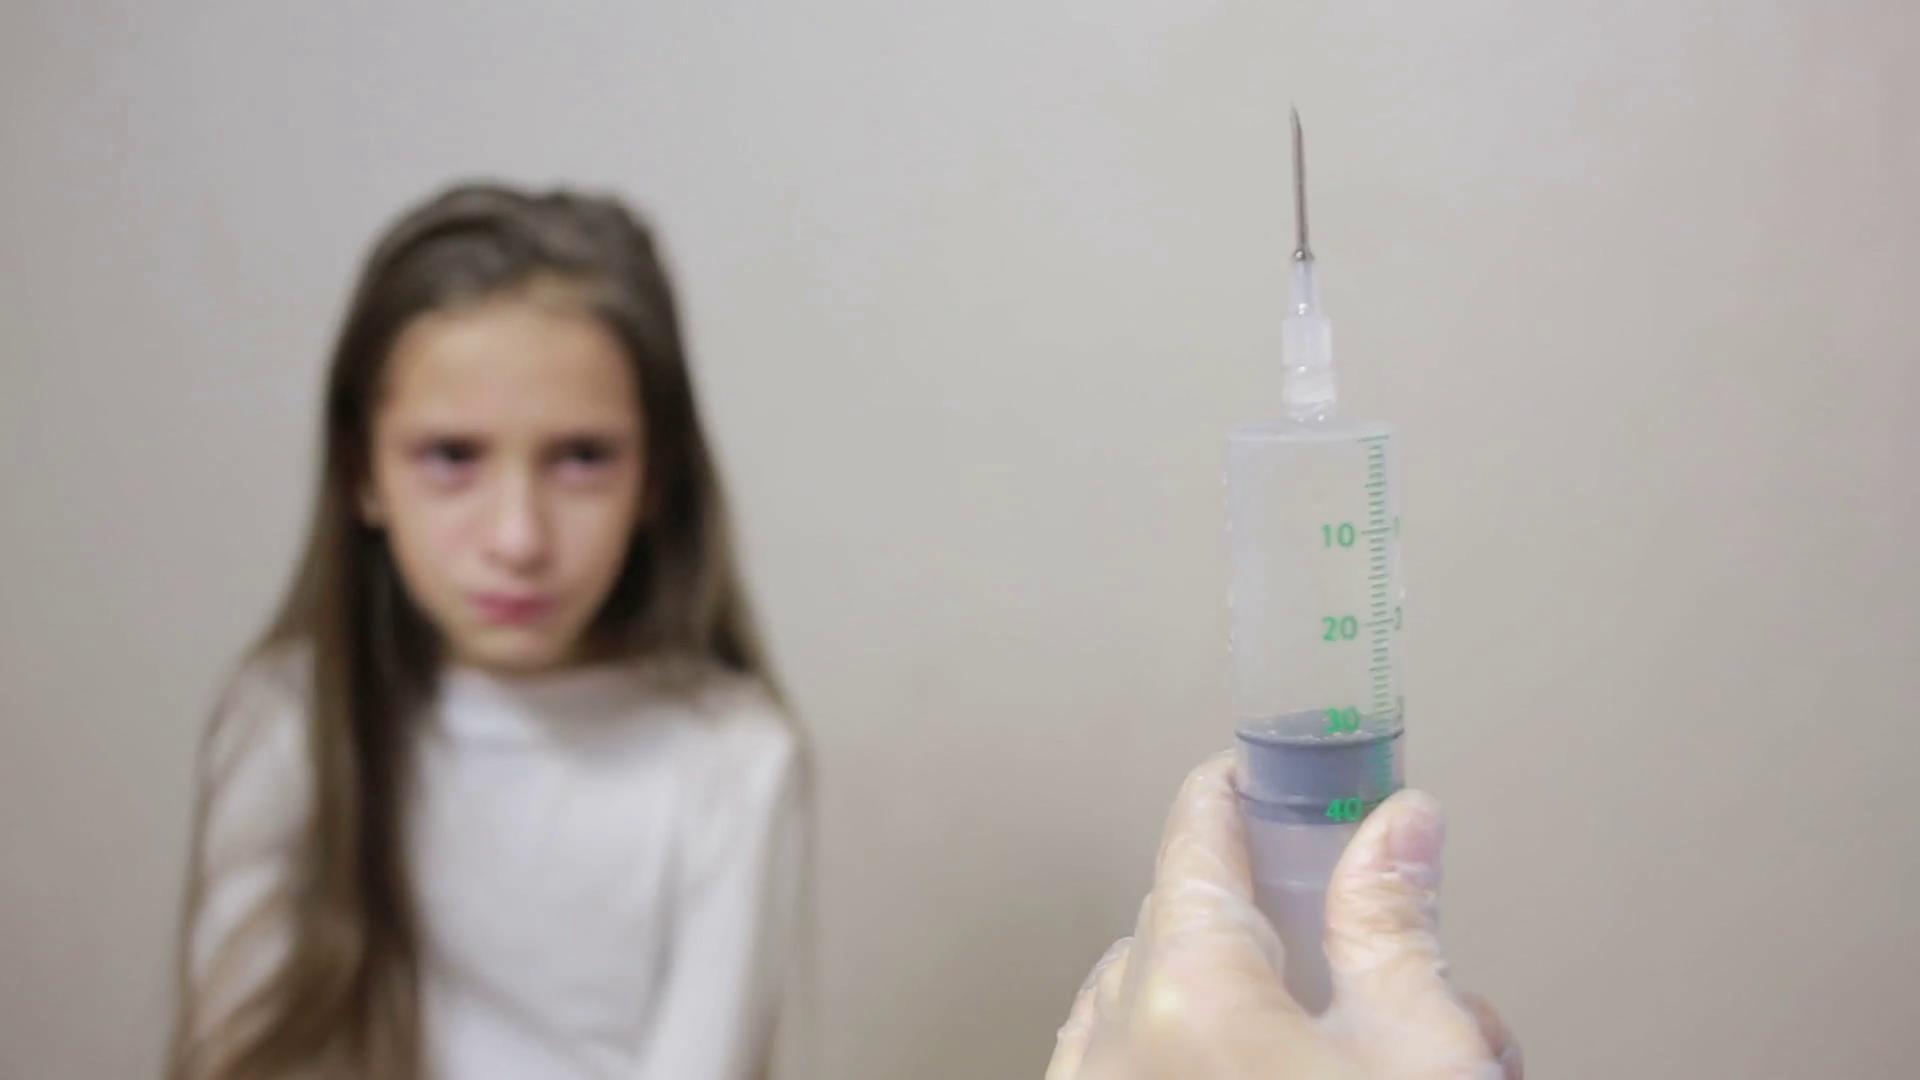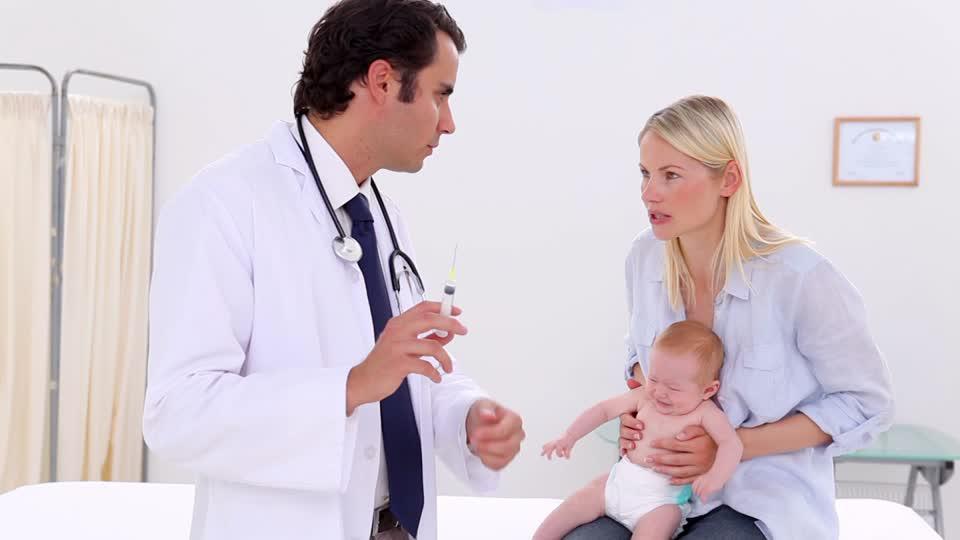The first image is the image on the left, the second image is the image on the right. Given the left and right images, does the statement "The left and right image contains two doctors and one patient." hold true? Answer yes or no. No. The first image is the image on the left, the second image is the image on the right. Analyze the images presented: Is the assertion "The right image shows a woman in a white lab coat holding up a hypodermic needle and looking at it." valid? Answer yes or no. No. 